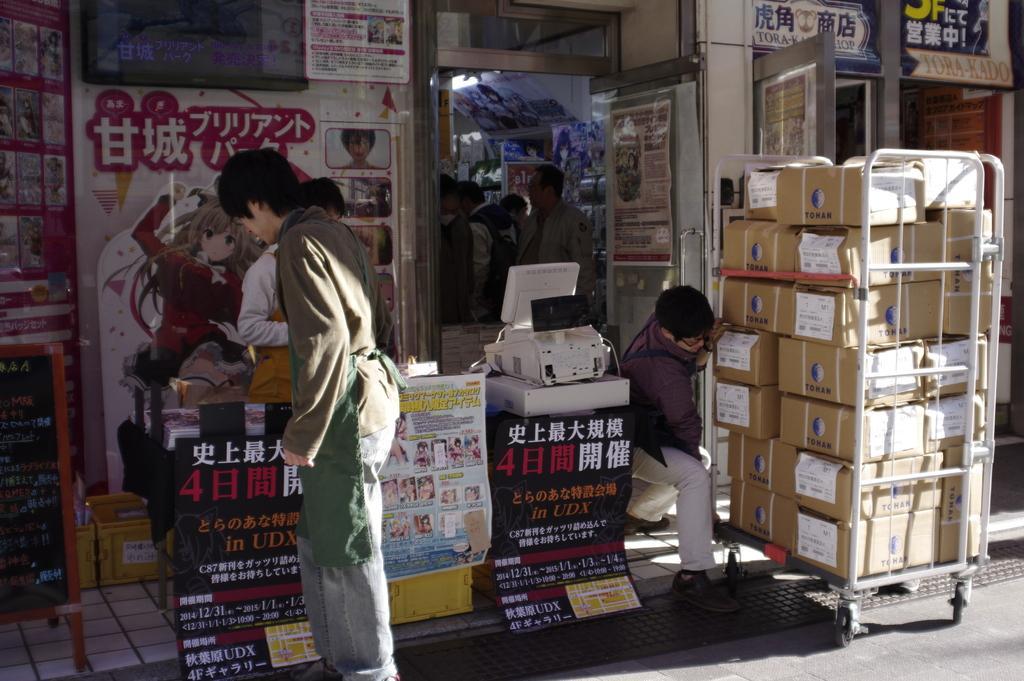Can you describe this image briefly? In this image it looks like it is a Chinese store in which there are so many people. On the right side there is a trolley on which there are so many cardboard boxes. The man is pushing the trolley. On the left side there is a person standing near the table. In the background there is a poster to the wall. On the left side there is a board on the floor. 